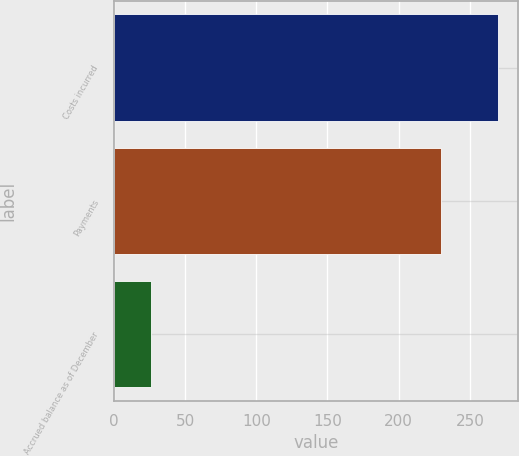Convert chart to OTSL. <chart><loc_0><loc_0><loc_500><loc_500><bar_chart><fcel>Costs incurred<fcel>Payments<fcel>Accrued balance as of December<nl><fcel>270<fcel>230<fcel>26<nl></chart> 